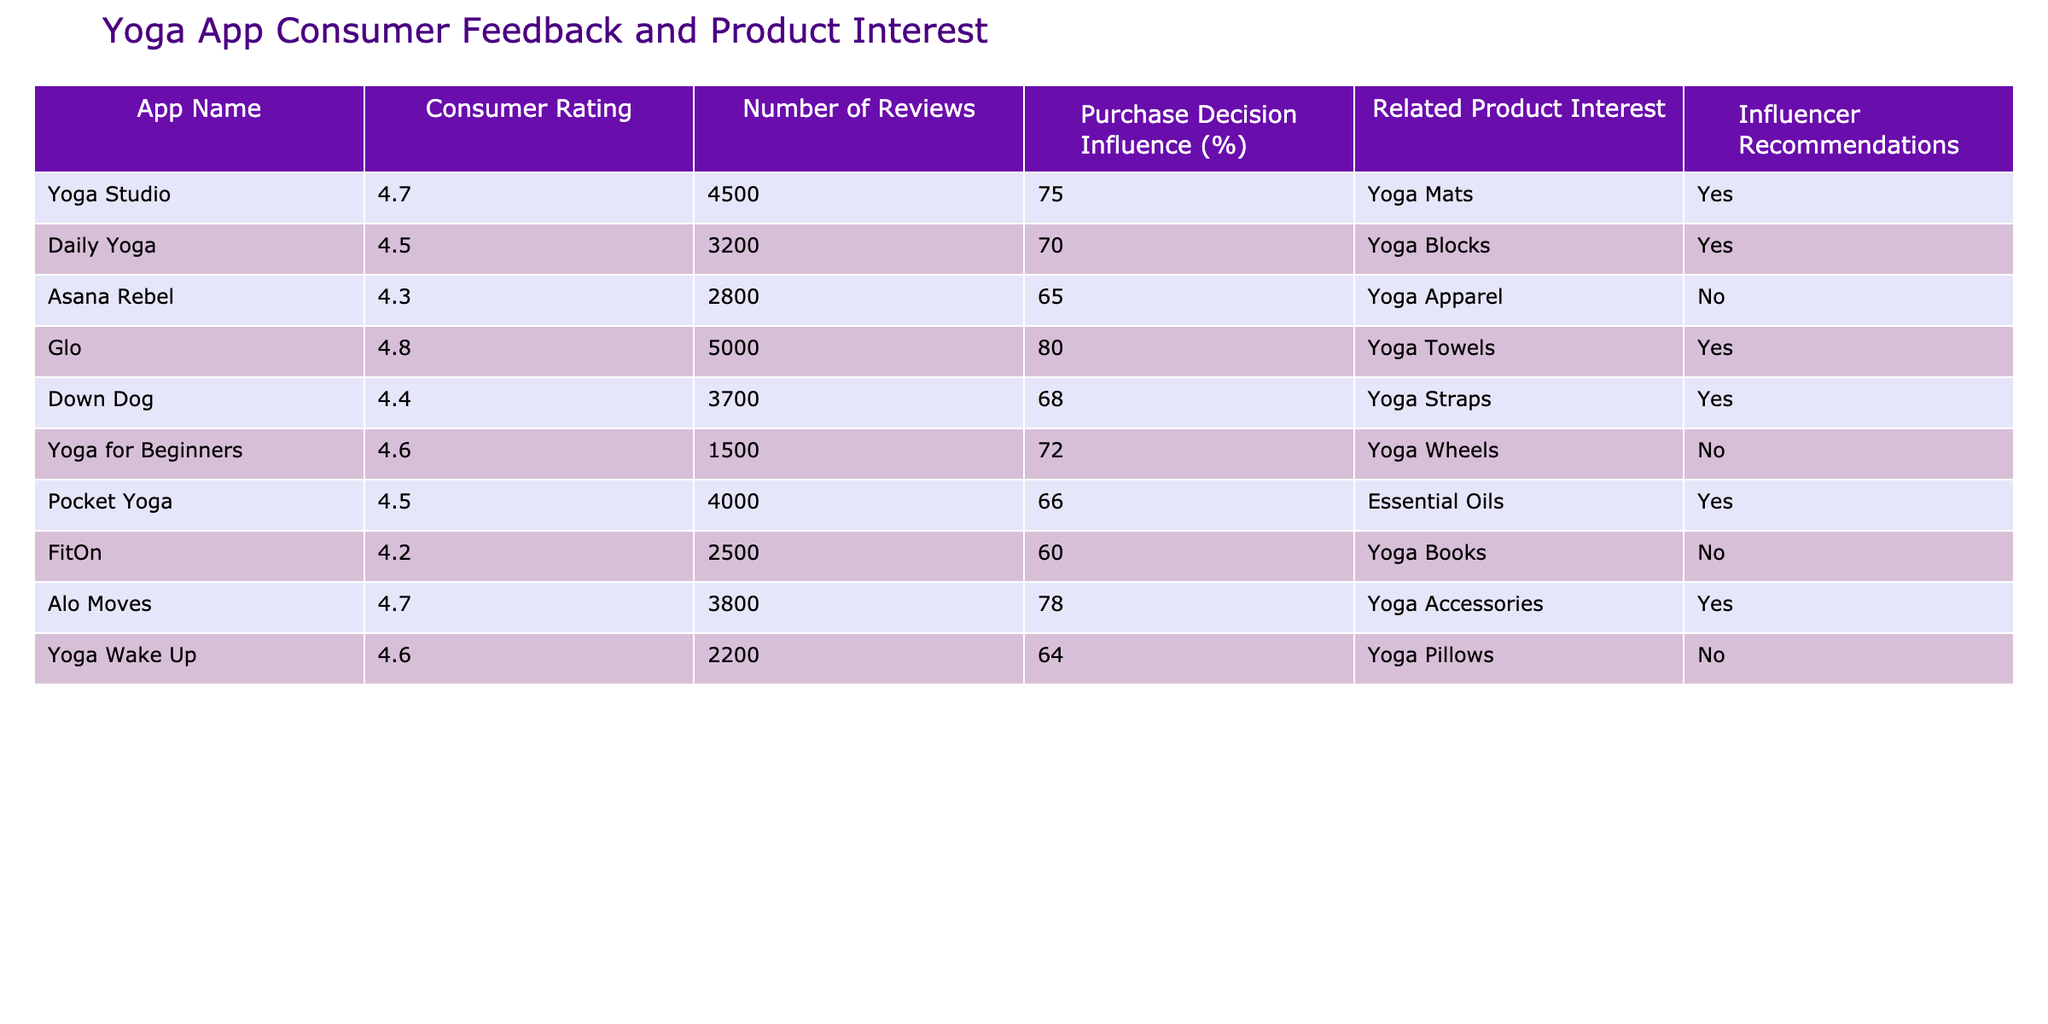What is the consumer rating of the Yoga Studio app? The Yoga Studio app is listed with a consumer rating of 4.7, which is directly visible in the table.
Answer: 4.7 How many reviews does the Glo app have? The Glo app has 5000 reviews, as noted in the corresponding cell of the table.
Answer: 5000 Which app has the highest influence on purchase decisions? The Glo app has the highest influence on purchase decisions at 80%. This value can be identified by comparing the "Purchase Decision Influence (%)" column.
Answer: Glo What is the average consumer rating of apps that provide influencer recommendations? The apps providing influencer recommendations are Yoga Studio (4.7), Daily Yoga (4.5), Glo (4.8), Down Dog (4.4), Pocket Yoga (4.5), Alo Moves (4.7). The average rating is calculated as (4.7 + 4.5 + 4.8 + 4.4 + 4.5 + 4.7) / 6 = 4.6.
Answer: 4.6 Is there any app related to yoga wheels that has an influence on purchase decisions? The Yoga for Beginners app is related to yoga wheels but does not have a significant influence on purchase decisions as its influence percentage is 72%, but it is marked 'No' for Influencer Recommendations, signaling a lack of indirect impact.
Answer: No Which app with more than 3000 reviews has the highest purchase decision influence? The Glo app, with 5000 reviews and an 80% influence on purchase decisions, meets these criteria. By filtering out apps with below 3000 reviews and checking the corresponding influence values, Glo stands out as the highest.
Answer: Glo How many apps listed have fewer than 3000 reviews? By checking the table, there are two apps with fewer than 3000 reviews: FitOn (2500 reviews) and Yoga for Beginners (1500 reviews), therefore the total is 2.
Answer: 2 What percentage of apps that provide influencer recommendations also interest consumers in yoga mats? Among the apps providing influencer recommendations, only the Yoga Studio app is associated with yoga mats, and there are 6 such apps in total. Therefore, the percentage is (1/6)*100 = 16.67%.
Answer: 16.67% 